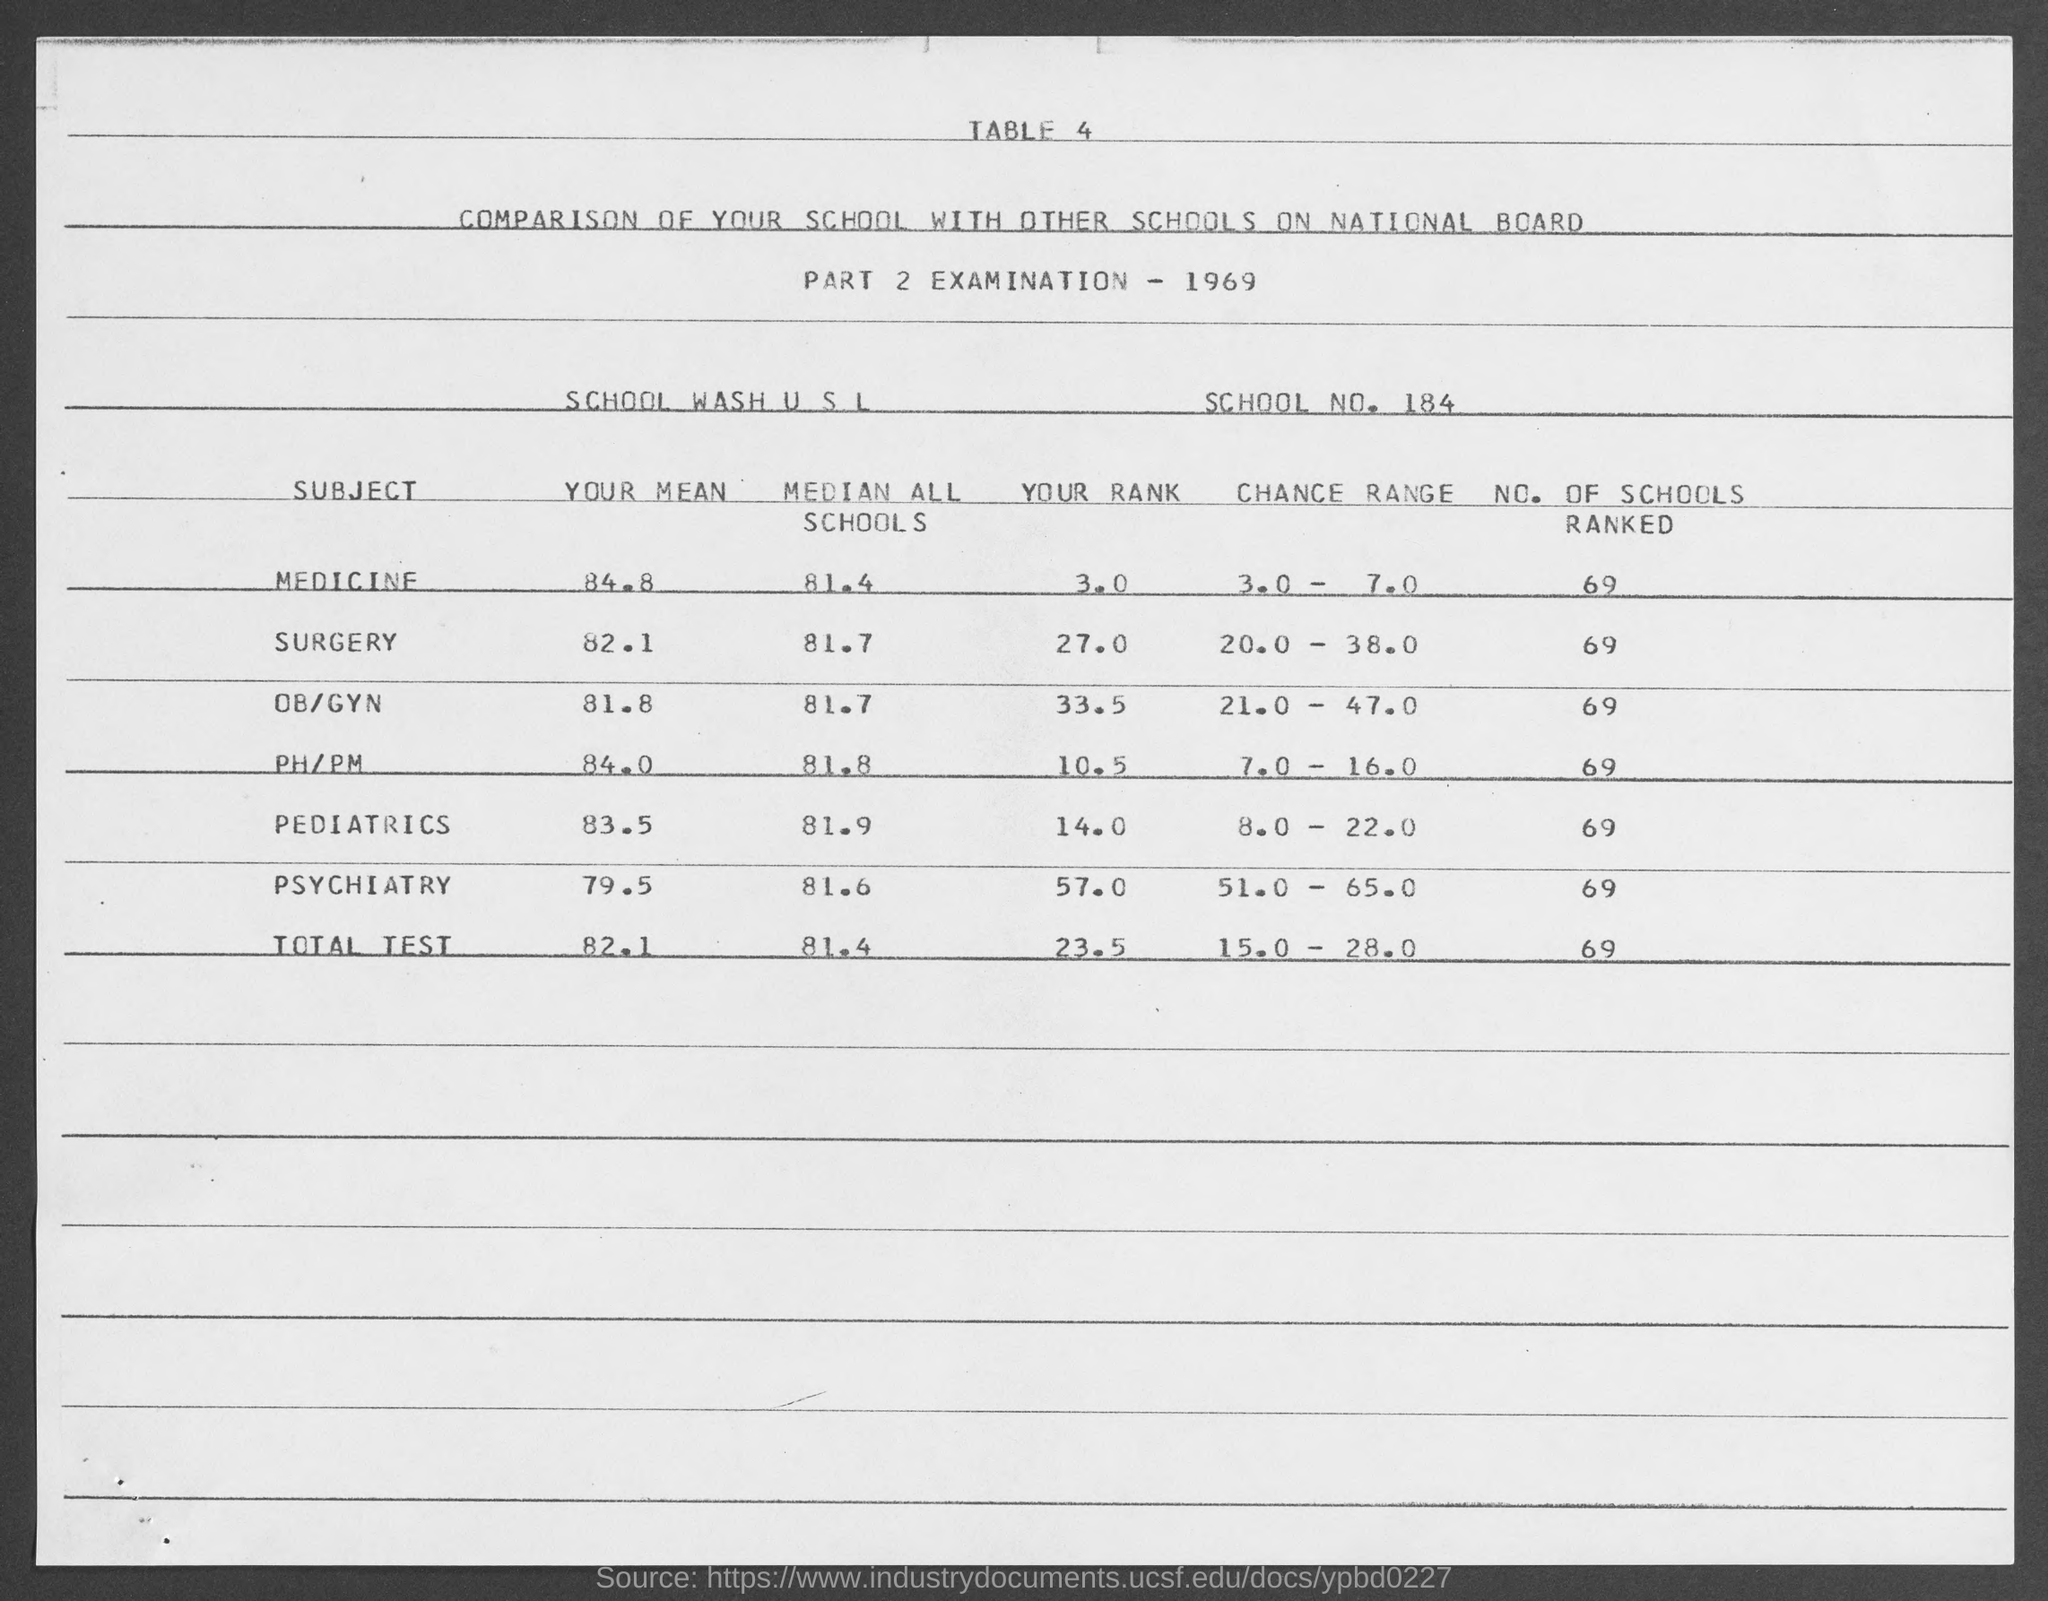What is the school no. mentioned in the document?
Provide a short and direct response. 184. What is the No. of schools ranked for pediatrics?
Offer a very short reply. 69. What is the No. of schools ranked for Medicine?
Offer a terse response. 69. What is the Median of all schools in total test conducted for all subjects given here?
Your response must be concise. 81.4. What is the Chance Range for total test conducted for all subjects given here?
Offer a very short reply. 15.0 - 28.0. 